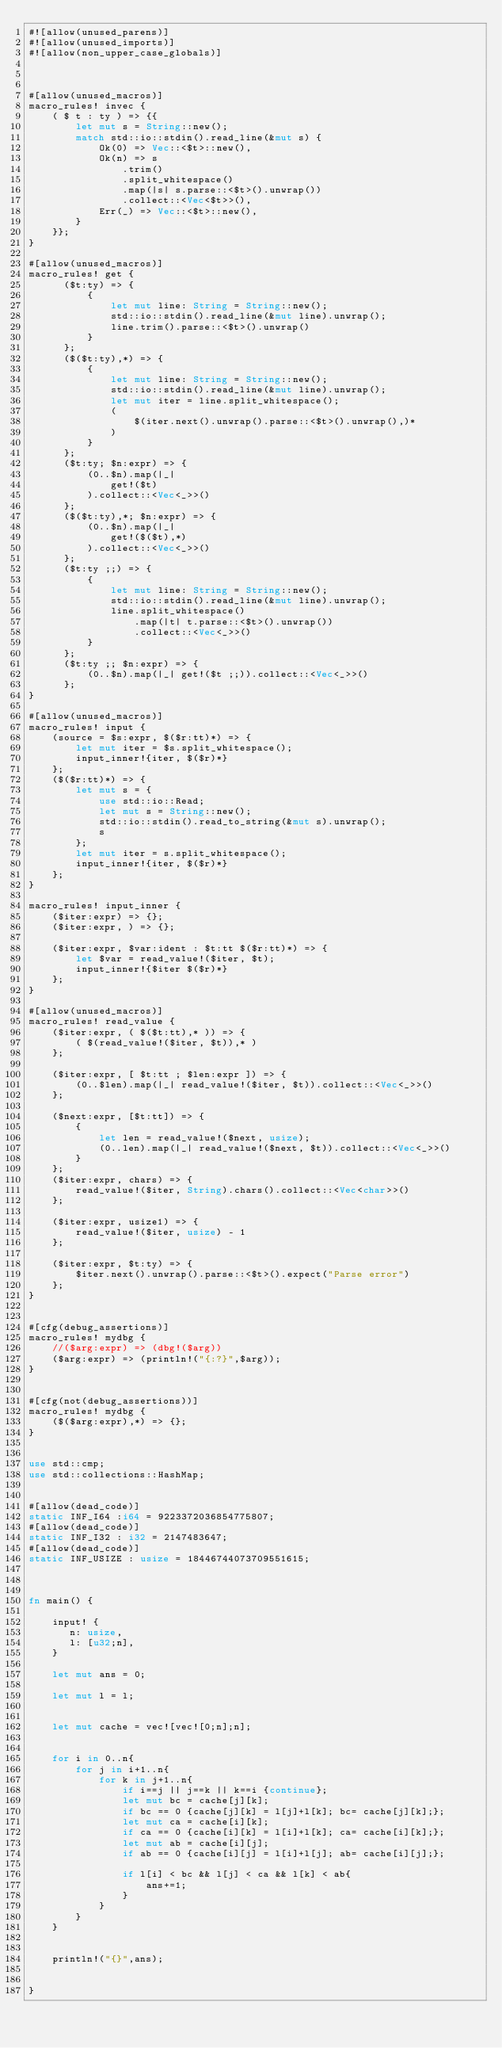Convert code to text. <code><loc_0><loc_0><loc_500><loc_500><_Rust_>#![allow(unused_parens)]
#![allow(unused_imports)]
#![allow(non_upper_case_globals)]



#[allow(unused_macros)]
macro_rules! invec {
    ( $ t : ty ) => {{
        let mut s = String::new();
        match std::io::stdin().read_line(&mut s) {
            Ok(0) => Vec::<$t>::new(),
            Ok(n) => s
                .trim()
                .split_whitespace()
                .map(|s| s.parse::<$t>().unwrap())
                .collect::<Vec<$t>>(),
            Err(_) => Vec::<$t>::new(),
        }
    }};
}

#[allow(unused_macros)]
macro_rules! get {
      ($t:ty) => {
          {
              let mut line: String = String::new();
              std::io::stdin().read_line(&mut line).unwrap();
              line.trim().parse::<$t>().unwrap()
          }
      };
      ($($t:ty),*) => {
          {
              let mut line: String = String::new();
              std::io::stdin().read_line(&mut line).unwrap();
              let mut iter = line.split_whitespace();
              (
                  $(iter.next().unwrap().parse::<$t>().unwrap(),)*
              )
          }
      };
      ($t:ty; $n:expr) => {
          (0..$n).map(|_|
              get!($t)
          ).collect::<Vec<_>>()
      };
      ($($t:ty),*; $n:expr) => {
          (0..$n).map(|_|
              get!($($t),*)
          ).collect::<Vec<_>>()
      };
      ($t:ty ;;) => {
          {
              let mut line: String = String::new();
              std::io::stdin().read_line(&mut line).unwrap();
              line.split_whitespace()
                  .map(|t| t.parse::<$t>().unwrap())
                  .collect::<Vec<_>>()
          }
      };
      ($t:ty ;; $n:expr) => {
          (0..$n).map(|_| get!($t ;;)).collect::<Vec<_>>()
      };
}

#[allow(unused_macros)]
macro_rules! input {
    (source = $s:expr, $($r:tt)*) => {
        let mut iter = $s.split_whitespace();
        input_inner!{iter, $($r)*}
    };
    ($($r:tt)*) => {
        let mut s = {
            use std::io::Read;
            let mut s = String::new();
            std::io::stdin().read_to_string(&mut s).unwrap();
            s
        };
        let mut iter = s.split_whitespace();
        input_inner!{iter, $($r)*}
    };
}

macro_rules! input_inner {
    ($iter:expr) => {};
    ($iter:expr, ) => {};

    ($iter:expr, $var:ident : $t:tt $($r:tt)*) => {
        let $var = read_value!($iter, $t);
        input_inner!{$iter $($r)*}
    };
}

#[allow(unused_macros)]
macro_rules! read_value {
    ($iter:expr, ( $($t:tt),* )) => {
        ( $(read_value!($iter, $t)),* )
    };

    ($iter:expr, [ $t:tt ; $len:expr ]) => {
        (0..$len).map(|_| read_value!($iter, $t)).collect::<Vec<_>>()
    };

    ($next:expr, [$t:tt]) => {
        {
            let len = read_value!($next, usize);
            (0..len).map(|_| read_value!($next, $t)).collect::<Vec<_>>()
        }
    };
    ($iter:expr, chars) => {
        read_value!($iter, String).chars().collect::<Vec<char>>()
    };

    ($iter:expr, usize1) => {
        read_value!($iter, usize) - 1
    };

    ($iter:expr, $t:ty) => {
        $iter.next().unwrap().parse::<$t>().expect("Parse error")
    };
}


#[cfg(debug_assertions)]
macro_rules! mydbg {
    //($arg:expr) => (dbg!($arg))
    ($arg:expr) => (println!("{:?}",$arg));
}


#[cfg(not(debug_assertions))]
macro_rules! mydbg {
    ($($arg:expr),*) => {};
}


use std::cmp;
use std::collections::HashMap;


#[allow(dead_code)]
static INF_I64 :i64 = 9223372036854775807;
#[allow(dead_code)]
static INF_I32 : i32 = 2147483647;
#[allow(dead_code)]
static INF_USIZE : usize = 18446744073709551615;



fn main() {

    input! { 
       n: usize,
       l: [u32;n],
    }

    let mut ans = 0;

    let mut l = l;


    let mut cache = vec![vec![0;n];n];


    for i in 0..n{
        for j in i+1..n{
            for k in j+1..n{
                if i==j || j==k || k==i {continue};
                let mut bc = cache[j][k];
                if bc == 0 {cache[j][k] = l[j]+l[k]; bc= cache[j][k];};
                let mut ca = cache[i][k];
                if ca == 0 {cache[i][k] = l[i]+l[k]; ca= cache[i][k];};
                let mut ab = cache[i][j];
                if ab == 0 {cache[i][j] = l[i]+l[j]; ab= cache[i][j];};
                
                if l[i] < bc && l[j] < ca && l[k] < ab{
                    ans+=1;
                }
            }
        }
    }
    
    
    println!("{}",ans);


}
</code> 